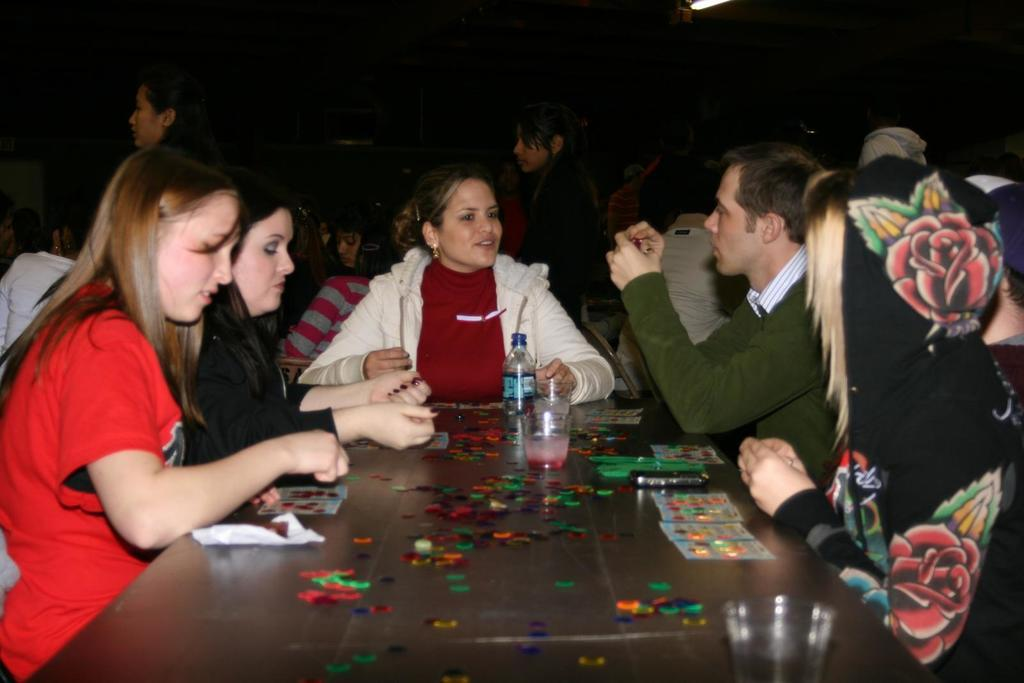How many people are in the image? There is a group of people in the image. What are the people doing in the image? The people are sitting on chairs. What is on the table in the image? There is a glass, a bottle, tablets, and balloons on the table. What is the source of light visible in the background? There is light visible in the background, but the specific source is not mentioned in the facts. What type of corn is being stored in the crate in the image? There is no crate or corn present in the image. How many horses are pulling the carriage in the image? There is no carriage or horses present in the image. 